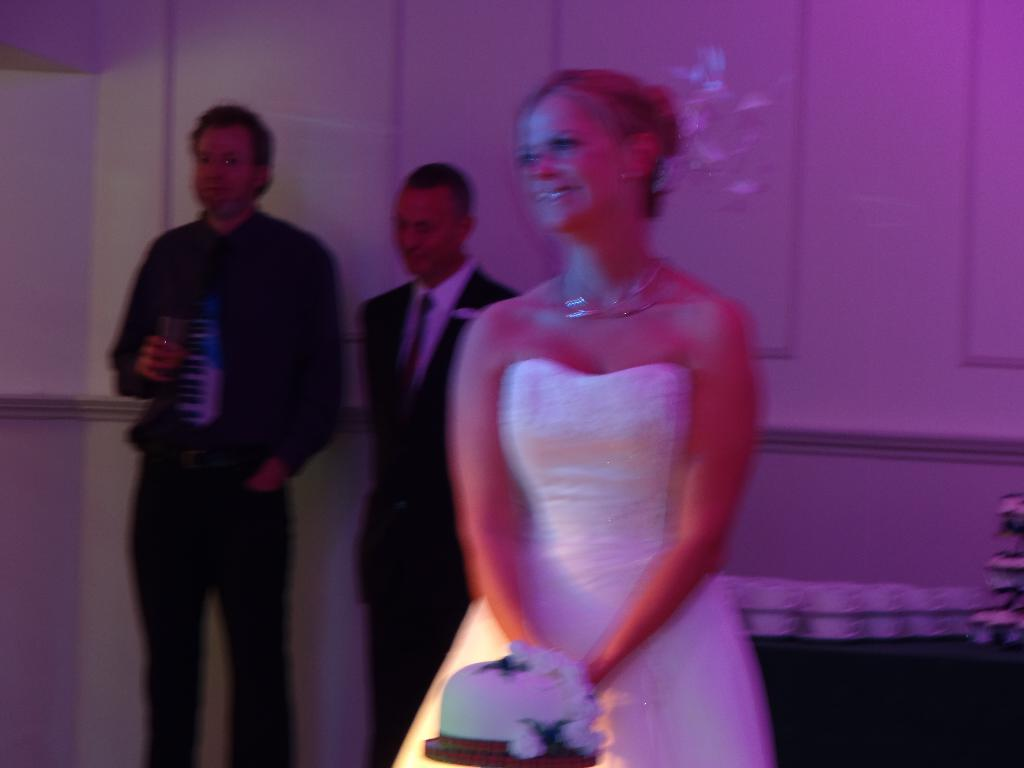What is the main object in the image? There is a cake in the image. Who is present in the image? A woman is standing in the image, wearing a white gown, and there are two people standing in the image. What can be seen in the background of the image? There is a wall visible in the image. What type of wren can be seen perched on the cake in the image? There is no wren present in the image, and the cake is not depicted with any birds or animals. 